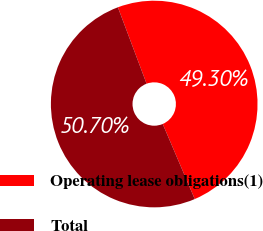<chart> <loc_0><loc_0><loc_500><loc_500><pie_chart><fcel>Operating lease obligations(1)<fcel>Total<nl><fcel>49.3%<fcel>50.7%<nl></chart> 